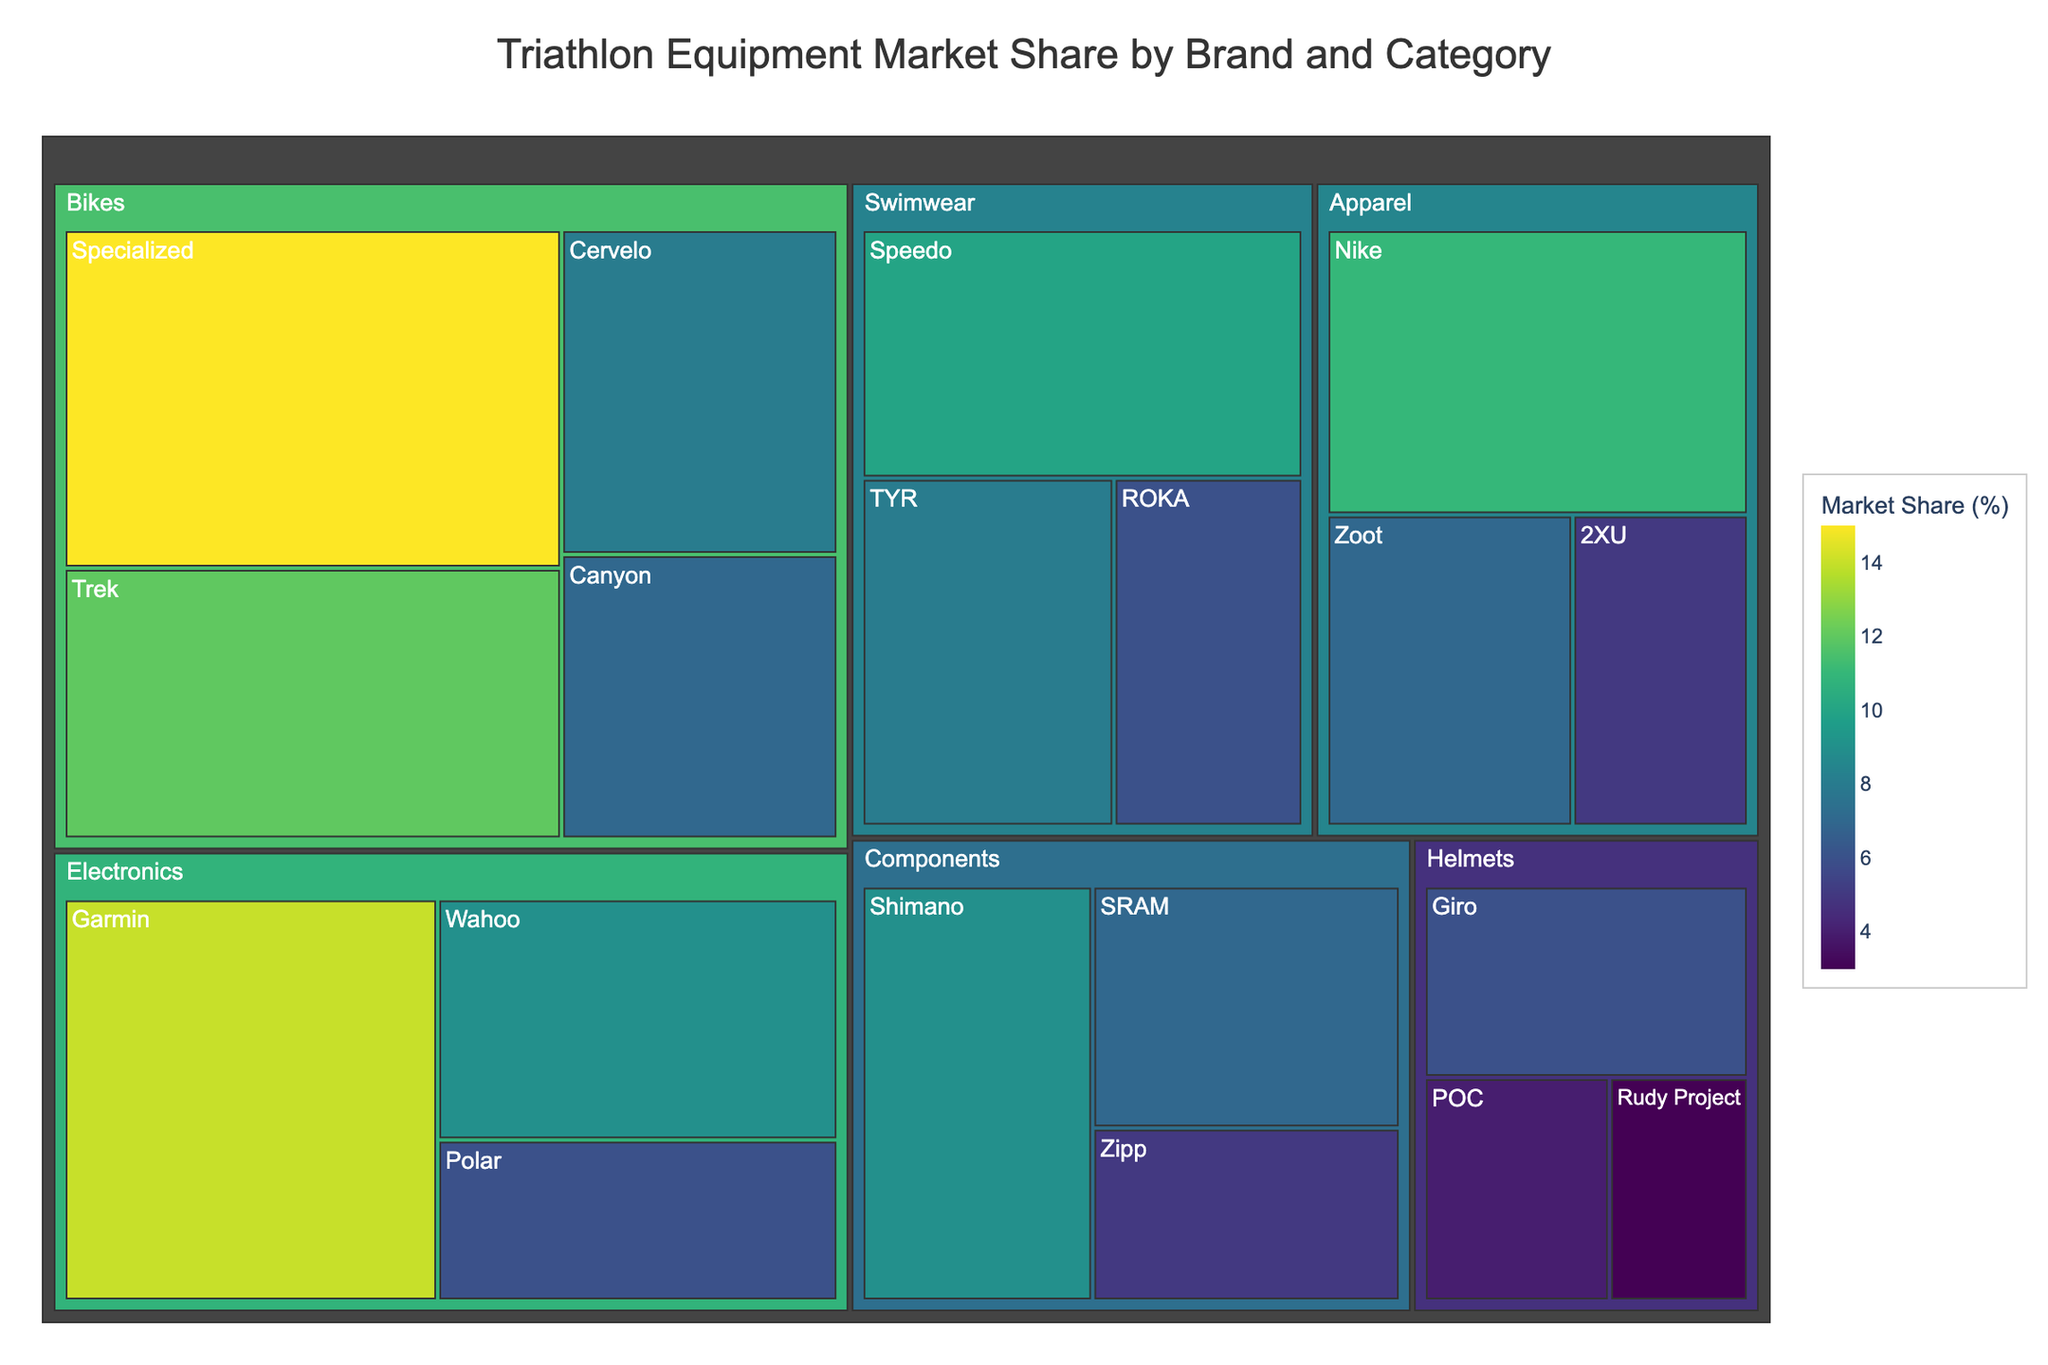What's the title of the Treemap? The title of the Treemap is usually placed at the top of the figure. It can be directly read from the figure without any calculations or complex reasoning.
Answer: "Triathlon Equipment Market Share by Brand and Category" Which brand has the highest market share in the Bikes category? To find this, look at the blocks in the Bikes category and identify the one with the largest size and percentage.
Answer: "Specialized" What is the total market share for the Electronics category? Sum the market shares of all brands within the Electronics category. Garmin has 14%, Wahoo has 9%, and Polar has 6%.
Answer: 29% Does the Swimwear category have a higher market share than the Apparel category? Add up the market shares of brands in both categories. Swimwear has 10% (Speedo) + 8% (TYR) + 6% (ROKA) = 24%. Apparel has 11% (Nike) + 7% (Zoot) + 5% (2XU) = 23%. Compare the totals.
Answer: No Which brand has a higher market share: Speedo or Shimano? Look at the sizes and percentages assigned to the two brands. Speedo has 10% in Swimwear, while Shimano has 9% in Components.
Answer: "Speedo" What is the average market share of brands in the Components category? Sum the market shares of Components brands and divide by the number of brands. (9% + 7% + 5%) / 3 = 21% / 3
Answer: 7% How many brands are represented in the Helmets category? Count the individual brands listed under the Helmets category in the Treemap. The brands under Helmets are Giro, POC, and Rudy Project.
Answer: 3 Which brand has the lowest market share in the Helmets category? Look at the smallest block in the Helmets category to find the brand with the lowest market share.
Answer: "Rudy Project" What is the combined market share of Specialized, Trek, and Cervelo in the Bikes category? Add the market shares of these three brands: 15% (Specialized) + 12% (Trek) + 8% (Cervelo).
Answer: 35% How does the market share of Garmin compare to that of Nike? Compare the market share percentages of Garmin (14%) and Nike (11%) directly from the Treemap.
Answer: Garmin has a higher market share than Nike 